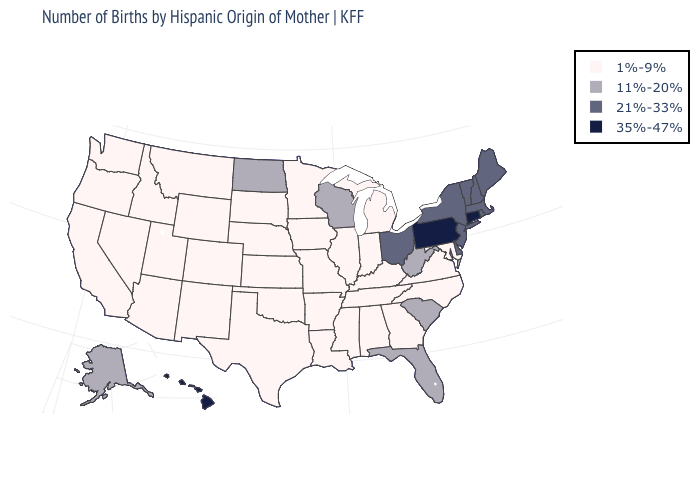What is the lowest value in the MidWest?
Write a very short answer. 1%-9%. What is the value of Mississippi?
Quick response, please. 1%-9%. Name the states that have a value in the range 11%-20%?
Concise answer only. Alaska, Florida, North Dakota, South Carolina, West Virginia, Wisconsin. Does Massachusetts have the lowest value in the Northeast?
Concise answer only. Yes. Name the states that have a value in the range 35%-47%?
Give a very brief answer. Connecticut, Hawaii, Pennsylvania. Which states have the highest value in the USA?
Be succinct. Connecticut, Hawaii, Pennsylvania. What is the value of Vermont?
Quick response, please. 21%-33%. Name the states that have a value in the range 1%-9%?
Be succinct. Alabama, Arizona, Arkansas, California, Colorado, Georgia, Idaho, Illinois, Indiana, Iowa, Kansas, Kentucky, Louisiana, Maryland, Michigan, Minnesota, Mississippi, Missouri, Montana, Nebraska, Nevada, New Mexico, North Carolina, Oklahoma, Oregon, South Dakota, Tennessee, Texas, Utah, Virginia, Washington, Wyoming. What is the highest value in the MidWest ?
Concise answer only. 21%-33%. Does Louisiana have the same value as North Dakota?
Give a very brief answer. No. Which states hav the highest value in the South?
Answer briefly. Delaware. Does Pennsylvania have the lowest value in the Northeast?
Be succinct. No. Name the states that have a value in the range 35%-47%?
Be succinct. Connecticut, Hawaii, Pennsylvania. Name the states that have a value in the range 21%-33%?
Write a very short answer. Delaware, Maine, Massachusetts, New Hampshire, New Jersey, New York, Ohio, Rhode Island, Vermont. Among the states that border California , which have the lowest value?
Answer briefly. Arizona, Nevada, Oregon. 